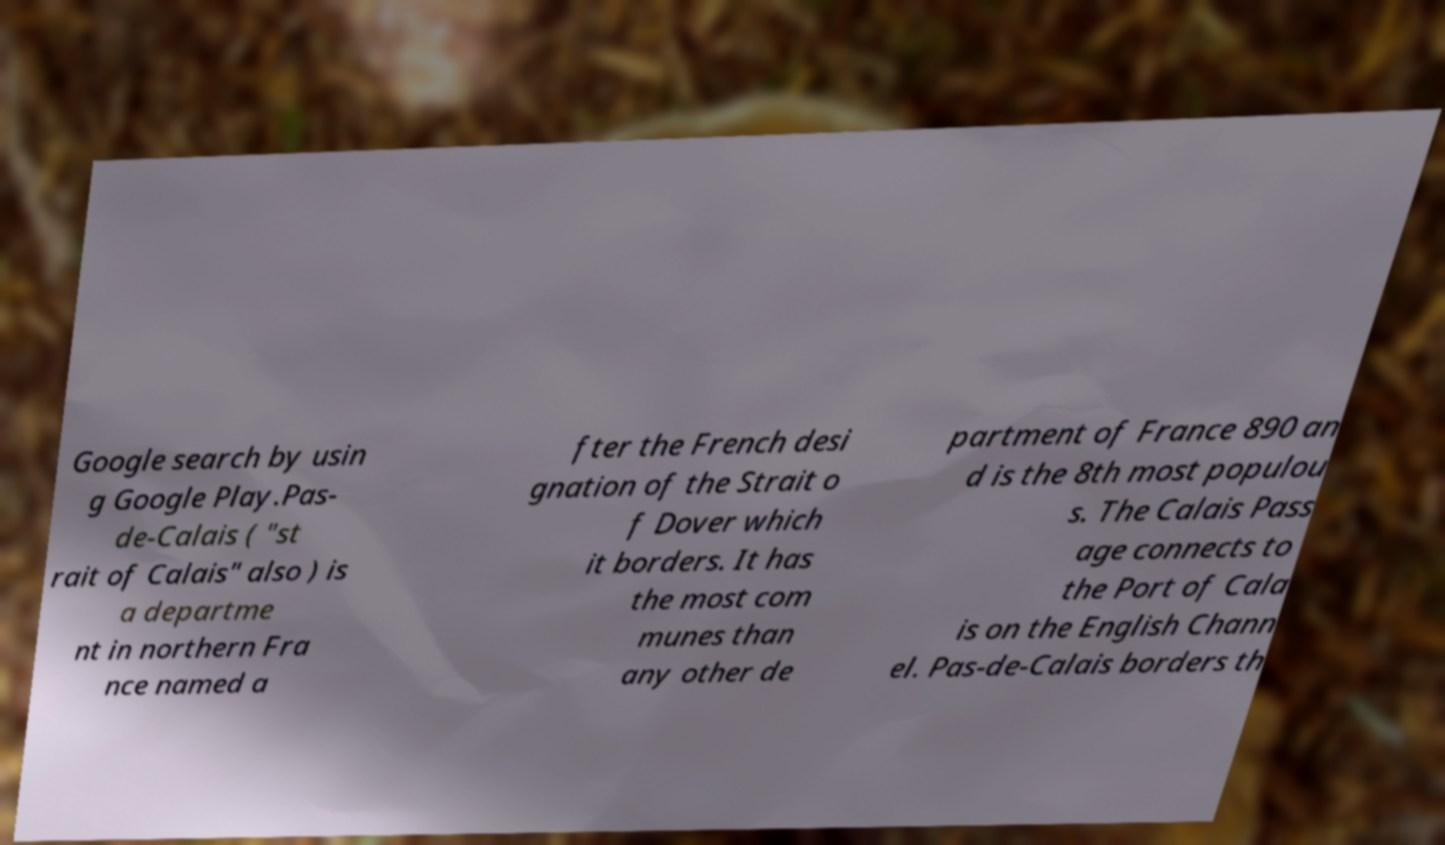Can you accurately transcribe the text from the provided image for me? Google search by usin g Google Play.Pas- de-Calais ( "st rait of Calais" also ) is a departme nt in northern Fra nce named a fter the French desi gnation of the Strait o f Dover which it borders. It has the most com munes than any other de partment of France 890 an d is the 8th most populou s. The Calais Pass age connects to the Port of Cala is on the English Chann el. Pas-de-Calais borders th 